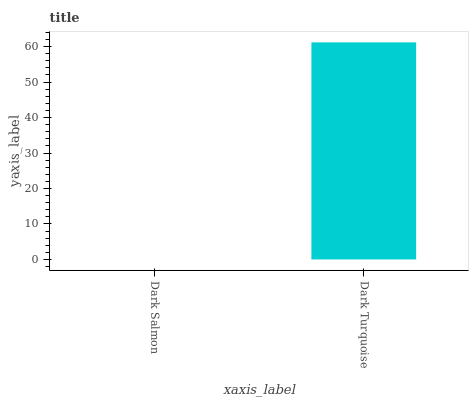Is Dark Salmon the minimum?
Answer yes or no. Yes. Is Dark Turquoise the maximum?
Answer yes or no. Yes. Is Dark Turquoise the minimum?
Answer yes or no. No. Is Dark Turquoise greater than Dark Salmon?
Answer yes or no. Yes. Is Dark Salmon less than Dark Turquoise?
Answer yes or no. Yes. Is Dark Salmon greater than Dark Turquoise?
Answer yes or no. No. Is Dark Turquoise less than Dark Salmon?
Answer yes or no. No. Is Dark Turquoise the high median?
Answer yes or no. Yes. Is Dark Salmon the low median?
Answer yes or no. Yes. Is Dark Salmon the high median?
Answer yes or no. No. Is Dark Turquoise the low median?
Answer yes or no. No. 